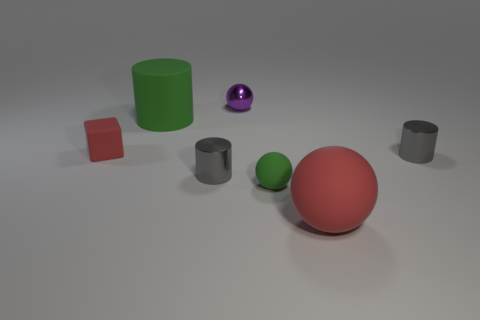There is a small sphere behind the green thing in front of the cube; how many gray objects are on the left side of it?
Your answer should be very brief. 1. There is a sphere that is behind the gray object to the right of the purple sphere; what color is it?
Your answer should be compact. Purple. What number of other things are made of the same material as the small green ball?
Provide a succinct answer. 3. There is a cylinder behind the block; how many big green matte objects are in front of it?
Keep it short and to the point. 0. Is there any other thing that is the same shape as the small purple thing?
Offer a very short reply. Yes. Is the color of the tiny thing that is left of the big green cylinder the same as the metal cylinder that is on the right side of the red ball?
Provide a short and direct response. No. Are there fewer tiny rubber balls than large brown cubes?
Your answer should be compact. No. The red matte thing that is right of the tiny cylinder that is on the left side of the large red ball is what shape?
Your response must be concise. Sphere. Is there any other thing that has the same size as the cube?
Your response must be concise. Yes. What shape is the large matte object behind the red object to the left of the tiny gray cylinder that is left of the small purple metallic object?
Offer a very short reply. Cylinder. 